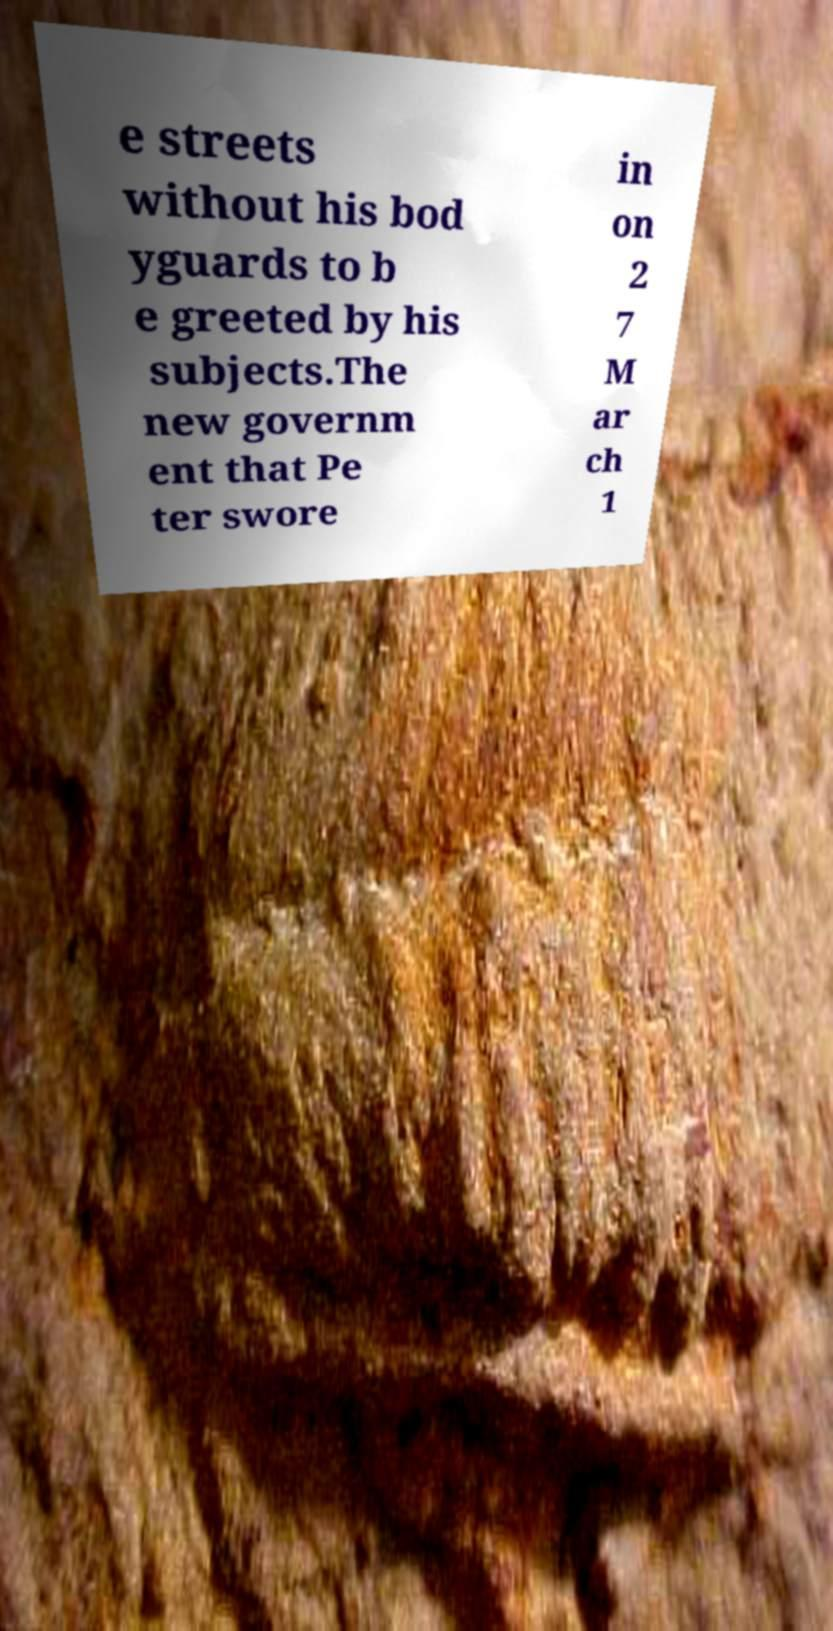For documentation purposes, I need the text within this image transcribed. Could you provide that? e streets without his bod yguards to b e greeted by his subjects.The new governm ent that Pe ter swore in on 2 7 M ar ch 1 